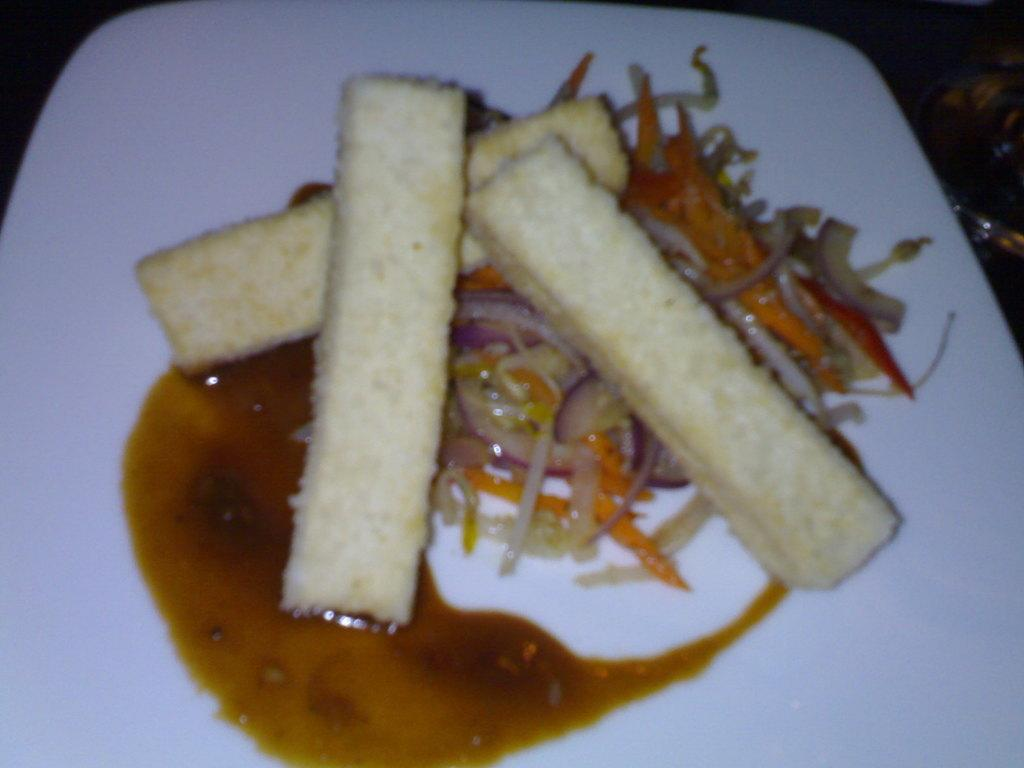What is on the plate in the image? There is a food item on the plate in the image. What can be observed about the food item? The food item contains onion pieces. Are there any other ingredients or components in the food item? There are other unspecified items in the food. What type of apparel is the onion wearing in the image? Onions do not wear apparel, as they are a type of vegetable and not a living being. 